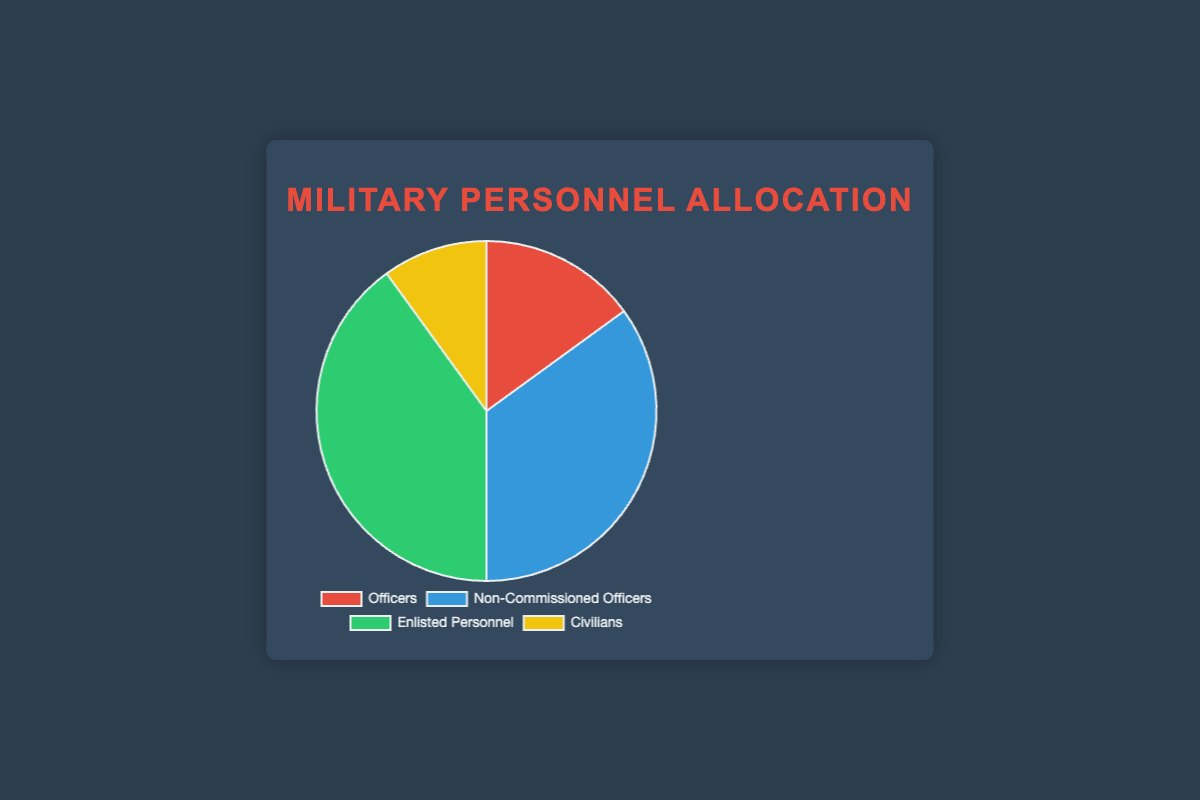What percentage of military personnel are non-commissioned officers? Looking at the chart, the segment for non-commissioned officers shows 35%.
Answer: 35% Which category has the smallest allocation of military personnel? By observing the pie chart, civilians have the smallest segment, representing 10%.
Answer: Civilians What is the combined percentage of officers and enlisted personnel? The percentage for officers is 15%, and for enlisted personnel, it is 40%. Adding these together: 15% + 40% = 55%.
Answer: 55% How much larger is the enlisted personnel segment compared to the officers segment? Enlisted personnel are at 40% and officers are at 15%. The difference is 40% - 15% = 25%.
Answer: 25% Are there more non-commissioned officers or civilians, and by what percentage? Non-commissioned officers are at 35%, and civilians are at 10%. The difference is 35% - 10% = 25%.
Answer: More non-commissioned officers by 25% Which two categories together make up half of the military personnel? Enlisted personnel are 40% and civilians are 10%. Together, they represent 40% + 10% = 50%.
Answer: Enlisted personnel and civilians Among non-commissioned officers and enlisted personnel, which category occupies a larger portion and what is the difference? Non-commissioned officers are at 35% and enlisted personnel are at 40%. The difference is 40% - 35% = 5%.
Answer: Enlisted personnel by 5% Visually, what color represents the officers segment? The color of the officers segment in the pie chart is red.
Answer: Red How do the percentages of non-commissioned officers and enlisted personnel compare to each other? Non-commissioned officers are at 35%, and enlisted personnel are at 40%. Enlisted personnel make up a larger portion.
Answer: Enlisted personnel have a larger portion What is the average percentage allocation of all four categories? Summing up the percentages: 15% (Officers) + 35% (Non-Commissioned Officers) + 40% (Enlisted Personnel) + 10% (Civilians) = 100%. The average is 100% / 4 = 25%.
Answer: 25% 